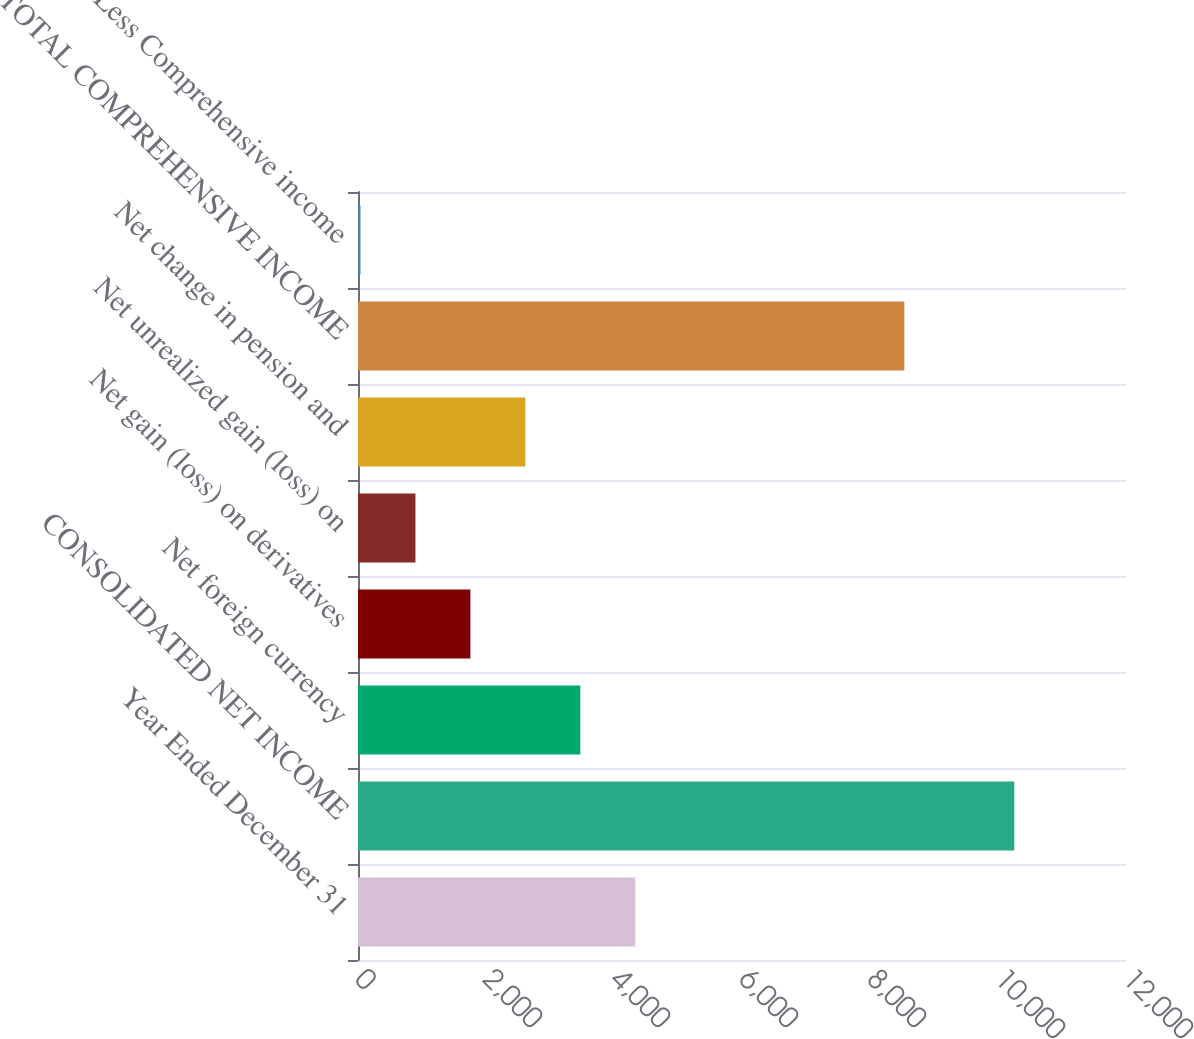<chart> <loc_0><loc_0><loc_500><loc_500><bar_chart><fcel>Year Ended December 31<fcel>CONSOLIDATED NET INCOME<fcel>Net foreign currency<fcel>Net gain (loss) on derivatives<fcel>Net unrealized gain (loss) on<fcel>Net change in pension and<fcel>TOTAL COMPREHENSIVE INCOME<fcel>Less Comprehensive income<nl><fcel>4332.5<fcel>10254.4<fcel>3473.8<fcel>1756.4<fcel>897.7<fcel>2615.1<fcel>8537<fcel>39<nl></chart> 